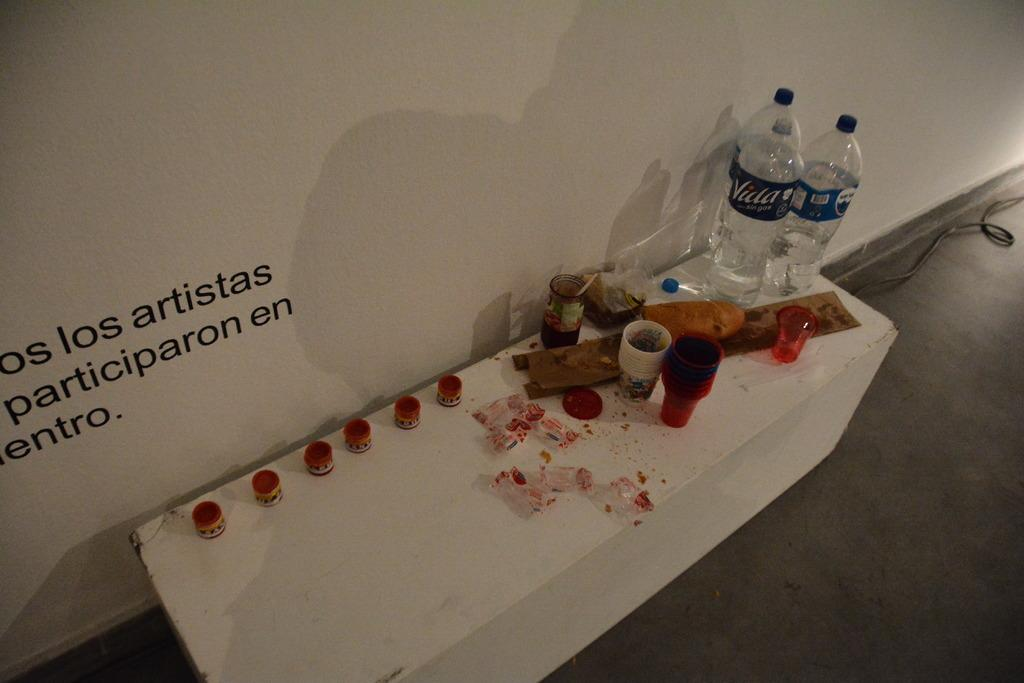<image>
Write a terse but informative summary of the picture. Two Villa water bottles at corner of table with multiple art supplies for artists to play with. 